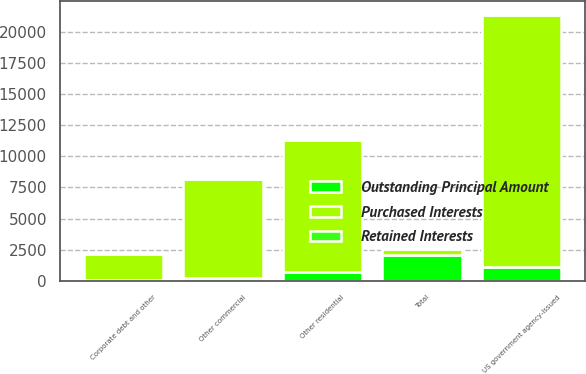<chart> <loc_0><loc_0><loc_500><loc_500><stacked_bar_chart><ecel><fcel>US government agency-issued<fcel>Other residential<fcel>Other commercial<fcel>Corporate debt and other<fcel>Total<nl><fcel>Purchased Interests<fcel>20232<fcel>10558<fcel>7916<fcel>2108<fcel>469.5<nl><fcel>Outstanding Principal Amount<fcel>1120<fcel>711<fcel>228<fcel>56<fcel>2115<nl><fcel>Retained Interests<fcel>16<fcel>17<fcel>7<fcel>1<fcel>41<nl></chart> 